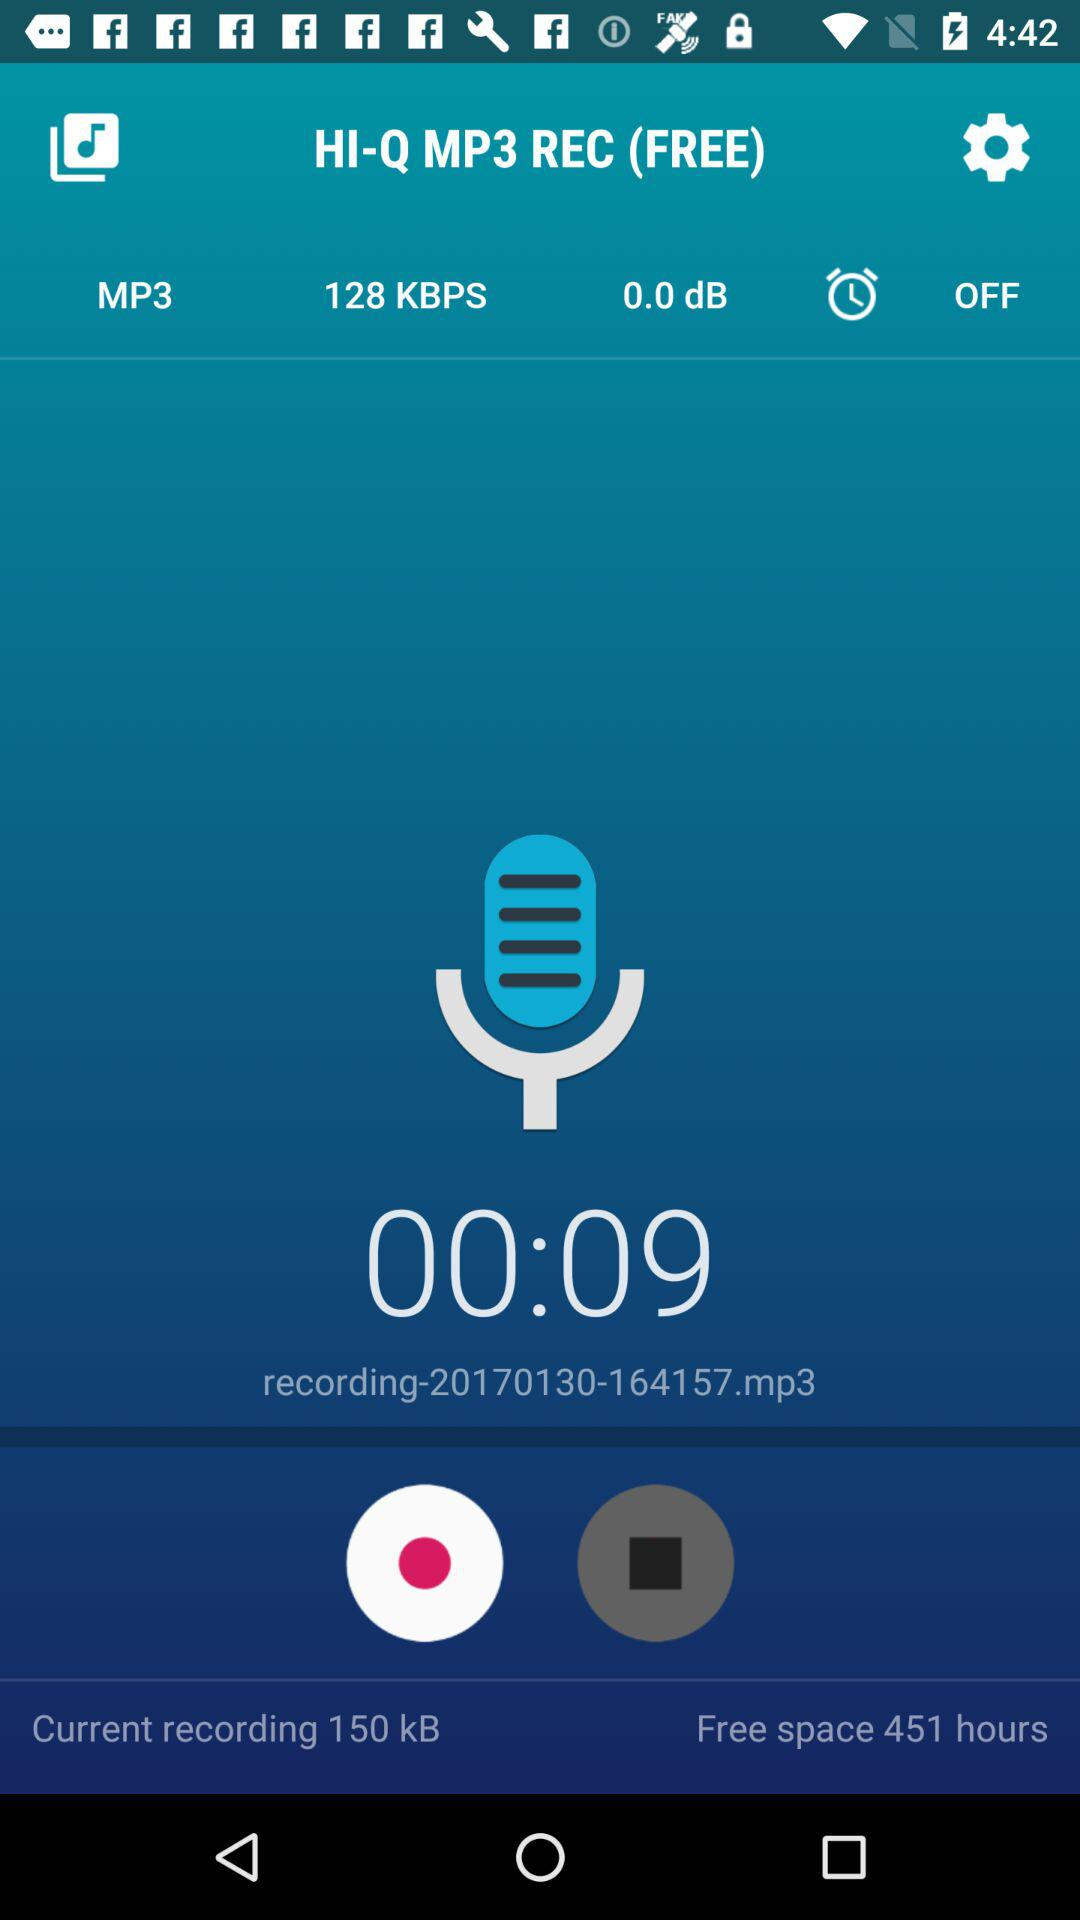How much storage space is used for recording? The used storage space is 150 kB. 